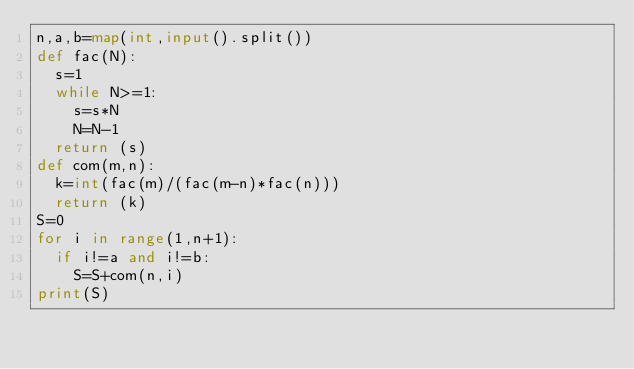<code> <loc_0><loc_0><loc_500><loc_500><_Python_>n,a,b=map(int,input().split())
def fac(N):
  s=1
  while N>=1:
    s=s*N
    N=N-1
  return (s)
def com(m,n):
  k=int(fac(m)/(fac(m-n)*fac(n)))
  return (k)
S=0
for i in range(1,n+1):
  if i!=a and i!=b:
    S=S+com(n,i)
print(S)</code> 